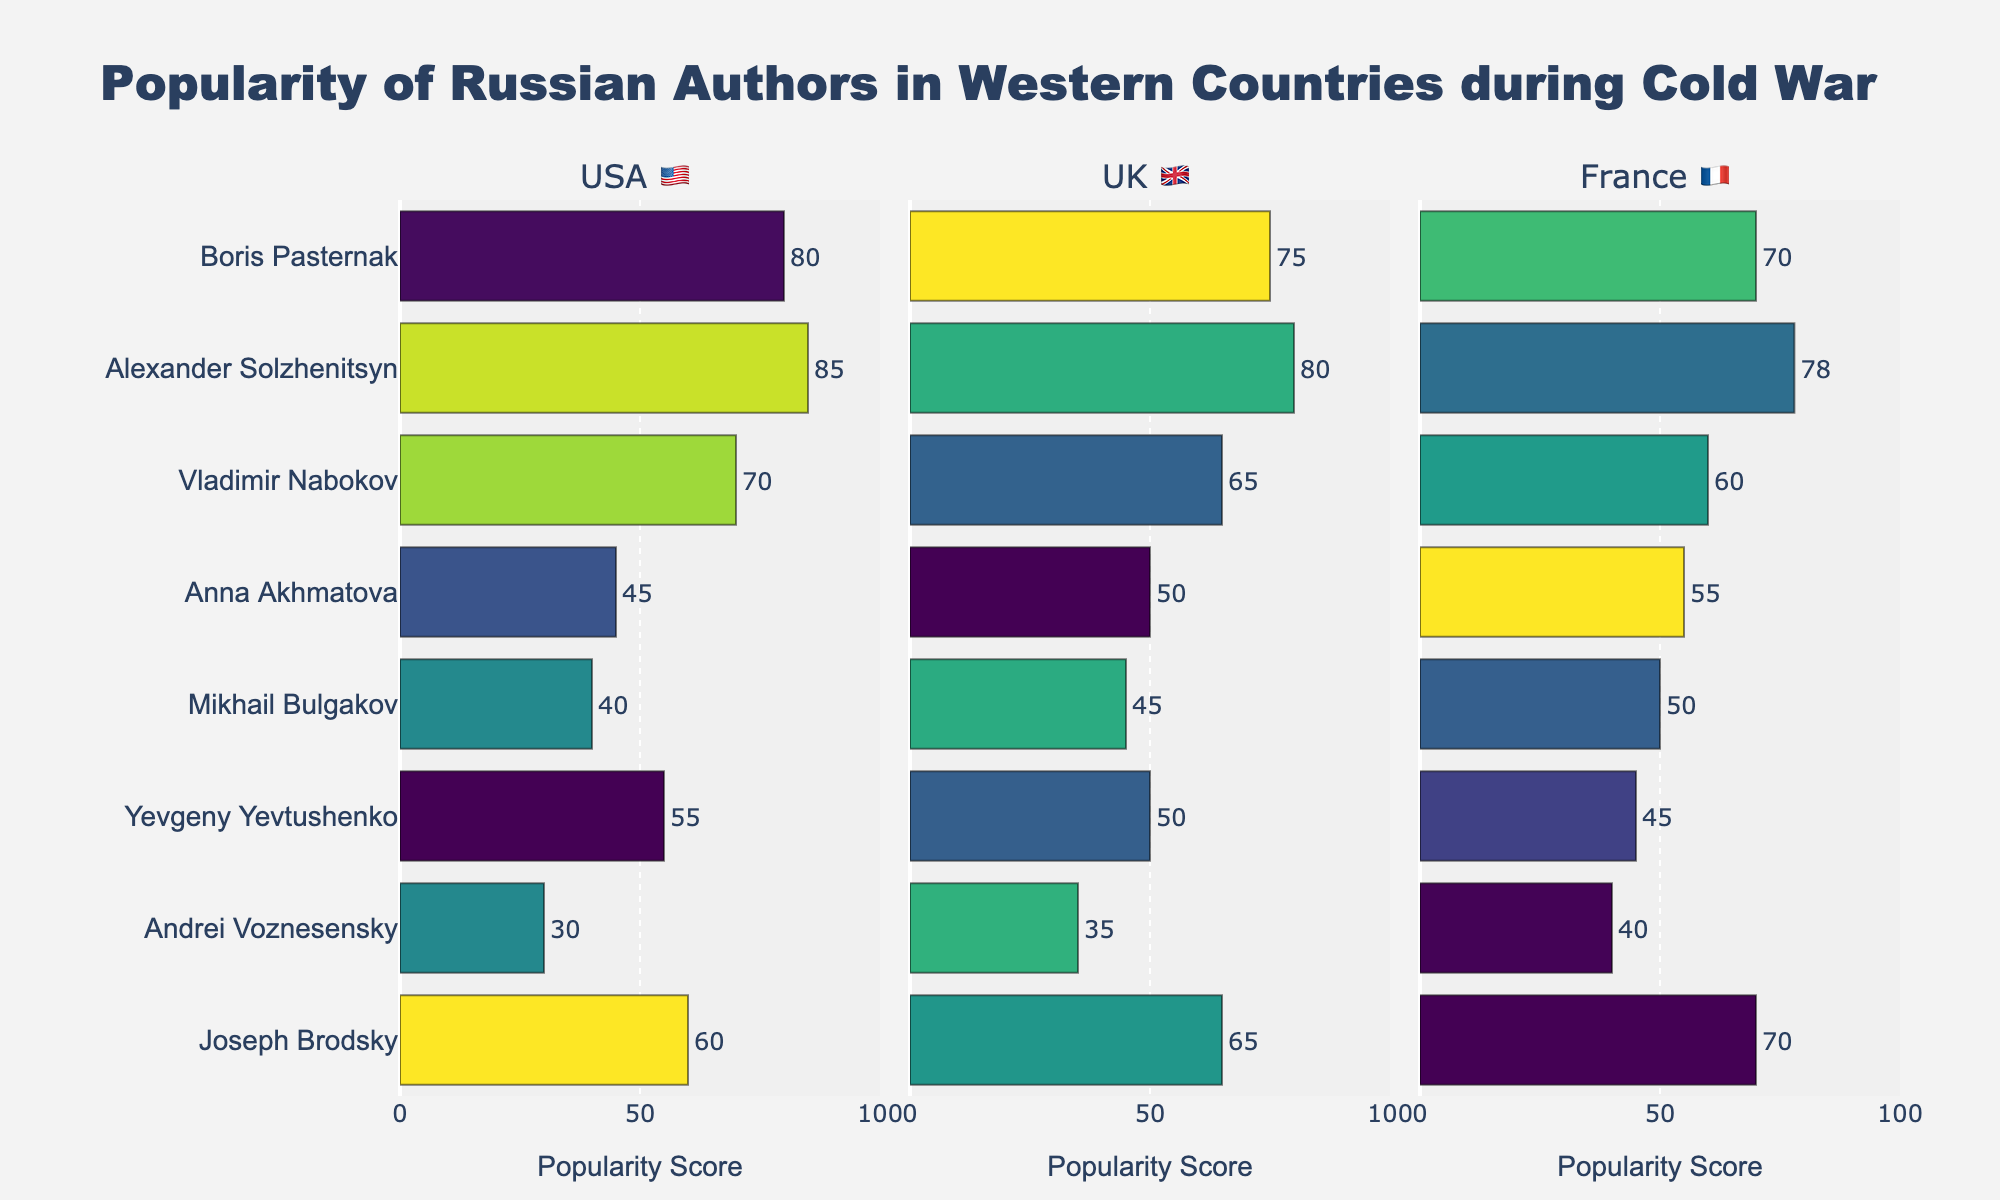Which author is the most popular among readers in the USA 🇺🇸? To find the author with the highest popularity score in the USA 🇺🇸, we look at the x-values in the USA 🇺🇸 subplot and find the highest value. Alexander Solzhenitsyn has the highest score of 85.
Answer: Alexander Solzhenitsyn Which of the displayed countries finds Anna Akhmatova most popular? We need to compare the popularity scores of Anna Akhmatova across USA 🇺🇸, UK 🇬🇧, and France 🇫🇷. Her scores are 45, 50, and 55, respectively. France 🇫🇷 has the highest score of 55.
Answer: France 🇫🇷 How does Vladimir Nabokov's popularity in France 🇫🇷 compare to his popularity in the UK 🇬🇧? Compare the scores in the France 🇫🇷 and UK 🇬🇧 subplots. Vladimir Nabokov's scores are 60 in France 🇫🇷 and 65 in the UK 🇬🇧, so he is more popular in the UK 🇬🇧.
Answer: More popular in the UK 🇬🇧 What's the difference in popularity between Boris Pasternak and Joseph Brodsky in the USA 🇺🇸? Subtract the popularity score of Joseph Brodsky from that of Boris Pasternak in the USA 🇺🇸 subplot: 80 - 60 = 20.
Answer: 20 Which author has exactly the same popularity score in the UK 🇬🇧 as in France 🇫🇷? We need to look for an author whose scores in the UK 🇬🇧 and France 🇫🇷 subplots are equal. Both Alexander Solzhenitsyn and Joseph Brodsky have scores that are very close; however, on closer inspection, their scores differ slightly.
Answer: None What is the average popularity score of Alexander Solzhenitsyn across the three countries? Add Alexander Solzhenitsyn's scores for USA 🇺🇸 (85), UK 🇬🇧 (80), and France 🇫🇷 (78), then divide by 3. (85 + 80 + 78) / 3 = 81.
Answer: 81 Which two authors have the closest popularity scores in France 🇫🇷? Compare the popularity scores in France 🇫🇷. Yevgeny Yevtushenko scores 45 and Andrei Voznesensky scores 40, with a difference of 5. This is the smallest difference among all authors.
Answer: Yevgeny Yevtushenko and Andrei Voznesensky Who is more popular in the UK 🇬🇧, Andrei Voznesensky or Mikhail Bulgakov? Compare their scores in the UK 🇬🇧 subplot. Andrei Voznesensky has a score of 35 and Mikhail Bulgakov has a score of 45, hence Mikhail Bulgakov is more popular.
Answer: Mikhail Bulgakov 